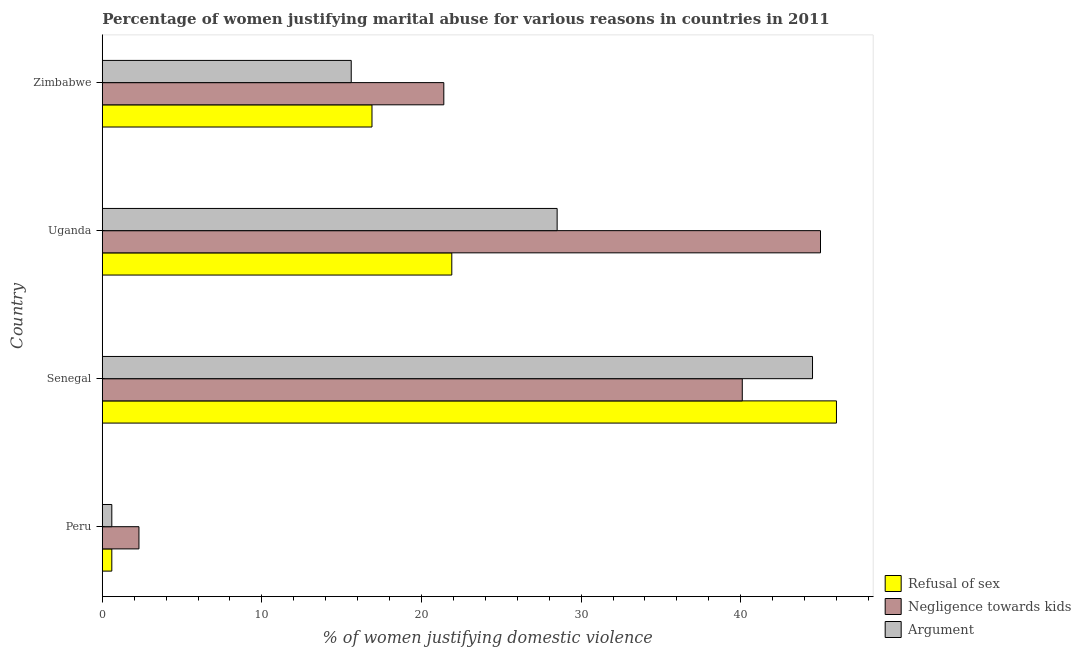How many different coloured bars are there?
Provide a succinct answer. 3. Are the number of bars on each tick of the Y-axis equal?
Provide a succinct answer. Yes. What is the label of the 4th group of bars from the top?
Your answer should be compact. Peru. In how many cases, is the number of bars for a given country not equal to the number of legend labels?
Your response must be concise. 0. What is the percentage of women justifying domestic violence due to refusal of sex in Uganda?
Offer a very short reply. 21.9. Across all countries, what is the maximum percentage of women justifying domestic violence due to refusal of sex?
Provide a short and direct response. 46. In which country was the percentage of women justifying domestic violence due to arguments maximum?
Provide a succinct answer. Senegal. What is the total percentage of women justifying domestic violence due to refusal of sex in the graph?
Your answer should be very brief. 85.4. What is the difference between the percentage of women justifying domestic violence due to arguments in Peru and that in Uganda?
Make the answer very short. -27.9. What is the difference between the percentage of women justifying domestic violence due to refusal of sex in Zimbabwe and the percentage of women justifying domestic violence due to negligence towards kids in Senegal?
Your answer should be compact. -23.2. What is the average percentage of women justifying domestic violence due to arguments per country?
Your answer should be very brief. 22.3. In how many countries, is the percentage of women justifying domestic violence due to refusal of sex greater than 38 %?
Keep it short and to the point. 1. What is the ratio of the percentage of women justifying domestic violence due to negligence towards kids in Peru to that in Senegal?
Provide a short and direct response. 0.06. Is the percentage of women justifying domestic violence due to negligence towards kids in Senegal less than that in Zimbabwe?
Make the answer very short. No. What is the difference between the highest and the lowest percentage of women justifying domestic violence due to refusal of sex?
Make the answer very short. 45.4. What does the 1st bar from the top in Peru represents?
Make the answer very short. Argument. What does the 3rd bar from the bottom in Senegal represents?
Your response must be concise. Argument. Is it the case that in every country, the sum of the percentage of women justifying domestic violence due to refusal of sex and percentage of women justifying domestic violence due to negligence towards kids is greater than the percentage of women justifying domestic violence due to arguments?
Offer a terse response. Yes. How many bars are there?
Make the answer very short. 12. Does the graph contain grids?
Offer a terse response. No. Where does the legend appear in the graph?
Offer a terse response. Bottom right. How many legend labels are there?
Your answer should be very brief. 3. What is the title of the graph?
Keep it short and to the point. Percentage of women justifying marital abuse for various reasons in countries in 2011. Does "Taxes" appear as one of the legend labels in the graph?
Provide a short and direct response. No. What is the label or title of the X-axis?
Your response must be concise. % of women justifying domestic violence. What is the label or title of the Y-axis?
Give a very brief answer. Country. What is the % of women justifying domestic violence of Refusal of sex in Peru?
Provide a succinct answer. 0.6. What is the % of women justifying domestic violence of Negligence towards kids in Peru?
Make the answer very short. 2.3. What is the % of women justifying domestic violence of Negligence towards kids in Senegal?
Your response must be concise. 40.1. What is the % of women justifying domestic violence of Argument in Senegal?
Your response must be concise. 44.5. What is the % of women justifying domestic violence of Refusal of sex in Uganda?
Your response must be concise. 21.9. What is the % of women justifying domestic violence in Refusal of sex in Zimbabwe?
Ensure brevity in your answer.  16.9. What is the % of women justifying domestic violence in Negligence towards kids in Zimbabwe?
Your response must be concise. 21.4. Across all countries, what is the maximum % of women justifying domestic violence in Refusal of sex?
Provide a succinct answer. 46. Across all countries, what is the maximum % of women justifying domestic violence of Argument?
Your response must be concise. 44.5. Across all countries, what is the minimum % of women justifying domestic violence of Refusal of sex?
Your answer should be very brief. 0.6. Across all countries, what is the minimum % of women justifying domestic violence in Argument?
Your answer should be compact. 0.6. What is the total % of women justifying domestic violence in Refusal of sex in the graph?
Provide a succinct answer. 85.4. What is the total % of women justifying domestic violence of Negligence towards kids in the graph?
Make the answer very short. 108.8. What is the total % of women justifying domestic violence of Argument in the graph?
Provide a short and direct response. 89.2. What is the difference between the % of women justifying domestic violence in Refusal of sex in Peru and that in Senegal?
Your answer should be very brief. -45.4. What is the difference between the % of women justifying domestic violence of Negligence towards kids in Peru and that in Senegal?
Provide a short and direct response. -37.8. What is the difference between the % of women justifying domestic violence in Argument in Peru and that in Senegal?
Your answer should be very brief. -43.9. What is the difference between the % of women justifying domestic violence of Refusal of sex in Peru and that in Uganda?
Give a very brief answer. -21.3. What is the difference between the % of women justifying domestic violence of Negligence towards kids in Peru and that in Uganda?
Offer a terse response. -42.7. What is the difference between the % of women justifying domestic violence in Argument in Peru and that in Uganda?
Provide a succinct answer. -27.9. What is the difference between the % of women justifying domestic violence in Refusal of sex in Peru and that in Zimbabwe?
Ensure brevity in your answer.  -16.3. What is the difference between the % of women justifying domestic violence in Negligence towards kids in Peru and that in Zimbabwe?
Keep it short and to the point. -19.1. What is the difference between the % of women justifying domestic violence in Refusal of sex in Senegal and that in Uganda?
Offer a terse response. 24.1. What is the difference between the % of women justifying domestic violence in Negligence towards kids in Senegal and that in Uganda?
Keep it short and to the point. -4.9. What is the difference between the % of women justifying domestic violence of Refusal of sex in Senegal and that in Zimbabwe?
Ensure brevity in your answer.  29.1. What is the difference between the % of women justifying domestic violence in Negligence towards kids in Senegal and that in Zimbabwe?
Ensure brevity in your answer.  18.7. What is the difference between the % of women justifying domestic violence in Argument in Senegal and that in Zimbabwe?
Give a very brief answer. 28.9. What is the difference between the % of women justifying domestic violence of Refusal of sex in Uganda and that in Zimbabwe?
Offer a terse response. 5. What is the difference between the % of women justifying domestic violence in Negligence towards kids in Uganda and that in Zimbabwe?
Make the answer very short. 23.6. What is the difference between the % of women justifying domestic violence in Refusal of sex in Peru and the % of women justifying domestic violence in Negligence towards kids in Senegal?
Your answer should be compact. -39.5. What is the difference between the % of women justifying domestic violence of Refusal of sex in Peru and the % of women justifying domestic violence of Argument in Senegal?
Ensure brevity in your answer.  -43.9. What is the difference between the % of women justifying domestic violence in Negligence towards kids in Peru and the % of women justifying domestic violence in Argument in Senegal?
Offer a terse response. -42.2. What is the difference between the % of women justifying domestic violence in Refusal of sex in Peru and the % of women justifying domestic violence in Negligence towards kids in Uganda?
Provide a short and direct response. -44.4. What is the difference between the % of women justifying domestic violence of Refusal of sex in Peru and the % of women justifying domestic violence of Argument in Uganda?
Give a very brief answer. -27.9. What is the difference between the % of women justifying domestic violence in Negligence towards kids in Peru and the % of women justifying domestic violence in Argument in Uganda?
Offer a terse response. -26.2. What is the difference between the % of women justifying domestic violence in Refusal of sex in Peru and the % of women justifying domestic violence in Negligence towards kids in Zimbabwe?
Offer a terse response. -20.8. What is the difference between the % of women justifying domestic violence in Refusal of sex in Senegal and the % of women justifying domestic violence in Negligence towards kids in Uganda?
Ensure brevity in your answer.  1. What is the difference between the % of women justifying domestic violence of Refusal of sex in Senegal and the % of women justifying domestic violence of Argument in Uganda?
Provide a short and direct response. 17.5. What is the difference between the % of women justifying domestic violence of Refusal of sex in Senegal and the % of women justifying domestic violence of Negligence towards kids in Zimbabwe?
Your response must be concise. 24.6. What is the difference between the % of women justifying domestic violence in Refusal of sex in Senegal and the % of women justifying domestic violence in Argument in Zimbabwe?
Your answer should be very brief. 30.4. What is the difference between the % of women justifying domestic violence of Refusal of sex in Uganda and the % of women justifying domestic violence of Negligence towards kids in Zimbabwe?
Offer a very short reply. 0.5. What is the difference between the % of women justifying domestic violence of Negligence towards kids in Uganda and the % of women justifying domestic violence of Argument in Zimbabwe?
Provide a short and direct response. 29.4. What is the average % of women justifying domestic violence in Refusal of sex per country?
Your answer should be very brief. 21.35. What is the average % of women justifying domestic violence of Negligence towards kids per country?
Your answer should be very brief. 27.2. What is the average % of women justifying domestic violence in Argument per country?
Give a very brief answer. 22.3. What is the difference between the % of women justifying domestic violence of Refusal of sex and % of women justifying domestic violence of Negligence towards kids in Peru?
Provide a short and direct response. -1.7. What is the difference between the % of women justifying domestic violence in Refusal of sex and % of women justifying domestic violence in Argument in Peru?
Your response must be concise. 0. What is the difference between the % of women justifying domestic violence of Refusal of sex and % of women justifying domestic violence of Negligence towards kids in Uganda?
Ensure brevity in your answer.  -23.1. What is the difference between the % of women justifying domestic violence in Refusal of sex and % of women justifying domestic violence in Argument in Uganda?
Ensure brevity in your answer.  -6.6. What is the difference between the % of women justifying domestic violence of Refusal of sex and % of women justifying domestic violence of Argument in Zimbabwe?
Ensure brevity in your answer.  1.3. What is the ratio of the % of women justifying domestic violence in Refusal of sex in Peru to that in Senegal?
Offer a very short reply. 0.01. What is the ratio of the % of women justifying domestic violence in Negligence towards kids in Peru to that in Senegal?
Your response must be concise. 0.06. What is the ratio of the % of women justifying domestic violence in Argument in Peru to that in Senegal?
Give a very brief answer. 0.01. What is the ratio of the % of women justifying domestic violence of Refusal of sex in Peru to that in Uganda?
Keep it short and to the point. 0.03. What is the ratio of the % of women justifying domestic violence in Negligence towards kids in Peru to that in Uganda?
Your answer should be very brief. 0.05. What is the ratio of the % of women justifying domestic violence of Argument in Peru to that in Uganda?
Offer a very short reply. 0.02. What is the ratio of the % of women justifying domestic violence of Refusal of sex in Peru to that in Zimbabwe?
Offer a terse response. 0.04. What is the ratio of the % of women justifying domestic violence of Negligence towards kids in Peru to that in Zimbabwe?
Ensure brevity in your answer.  0.11. What is the ratio of the % of women justifying domestic violence of Argument in Peru to that in Zimbabwe?
Offer a very short reply. 0.04. What is the ratio of the % of women justifying domestic violence of Refusal of sex in Senegal to that in Uganda?
Your response must be concise. 2.1. What is the ratio of the % of women justifying domestic violence of Negligence towards kids in Senegal to that in Uganda?
Your answer should be compact. 0.89. What is the ratio of the % of women justifying domestic violence in Argument in Senegal to that in Uganda?
Give a very brief answer. 1.56. What is the ratio of the % of women justifying domestic violence in Refusal of sex in Senegal to that in Zimbabwe?
Provide a succinct answer. 2.72. What is the ratio of the % of women justifying domestic violence in Negligence towards kids in Senegal to that in Zimbabwe?
Your answer should be very brief. 1.87. What is the ratio of the % of women justifying domestic violence in Argument in Senegal to that in Zimbabwe?
Your answer should be compact. 2.85. What is the ratio of the % of women justifying domestic violence in Refusal of sex in Uganda to that in Zimbabwe?
Your response must be concise. 1.3. What is the ratio of the % of women justifying domestic violence of Negligence towards kids in Uganda to that in Zimbabwe?
Keep it short and to the point. 2.1. What is the ratio of the % of women justifying domestic violence in Argument in Uganda to that in Zimbabwe?
Your answer should be very brief. 1.83. What is the difference between the highest and the second highest % of women justifying domestic violence in Refusal of sex?
Provide a short and direct response. 24.1. What is the difference between the highest and the second highest % of women justifying domestic violence in Argument?
Offer a very short reply. 16. What is the difference between the highest and the lowest % of women justifying domestic violence in Refusal of sex?
Keep it short and to the point. 45.4. What is the difference between the highest and the lowest % of women justifying domestic violence in Negligence towards kids?
Give a very brief answer. 42.7. What is the difference between the highest and the lowest % of women justifying domestic violence in Argument?
Your response must be concise. 43.9. 